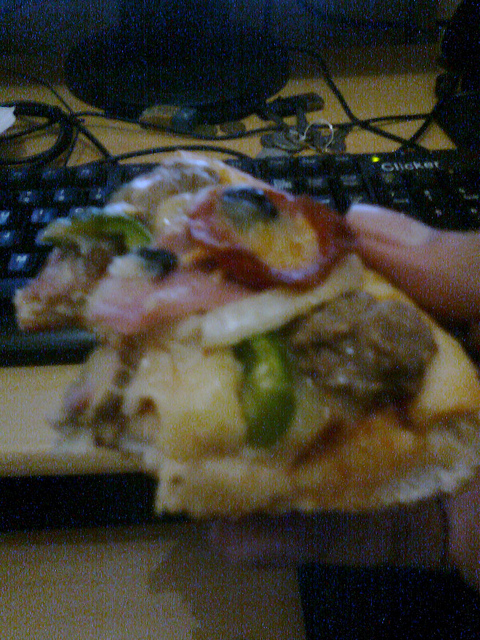Is the person wearing gloves? It's not possible to tell from this image if the person is wearing gloves as their hands are not visible. 